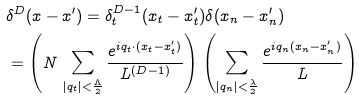Convert formula to latex. <formula><loc_0><loc_0><loc_500><loc_500>& \delta ^ { D } ( { x - x ^ { \prime } } ) = \delta ^ { D - 1 } _ { t } ( { x _ { t } - x _ { t } ^ { \prime } } ) \delta ( x _ { n } - x _ { n } ^ { \prime } ) \\ & = \left ( N \, \sum _ { | { q _ { t } } | < \frac { \Lambda } { 2 } } \frac { e ^ { i { q _ { t } } \cdot ( { x _ { t } - x _ { t } ^ { \prime } } ) } } { L ^ { ( D - 1 ) } } \right ) \left ( \sum _ { | { q _ { n } } | < \frac { \lambda } { 2 } } \frac { e ^ { i q _ { n } ( x _ { n } - x _ { n } ^ { \prime } ) } } { L } \right )</formula> 